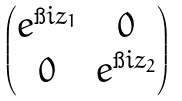Convert formula to latex. <formula><loc_0><loc_0><loc_500><loc_500>\begin{pmatrix} e ^ { \i i z _ { 1 } } & 0 \\ 0 & e ^ { \i i z _ { 2 } } \end{pmatrix}</formula> 